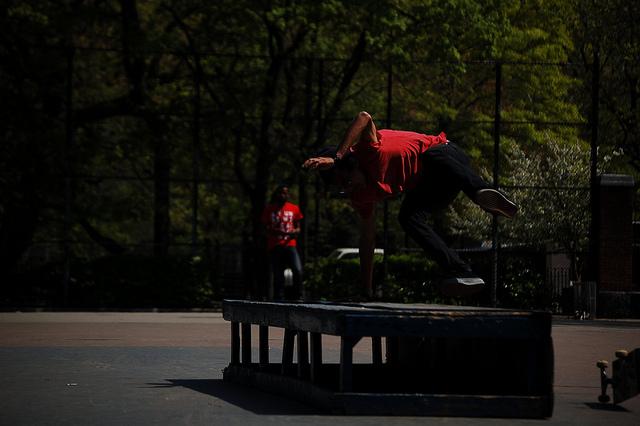What is the man doing?
Be succinct. Jumping. Is that man hurt?
Give a very brief answer. No. What color is the man shirt?
Be succinct. Red. What type of tree is in the background?
Write a very short answer. Oak. What material are the bench legs made of?
Short answer required. Metal. Are there umbrellas in this picture?
Answer briefly. No. 